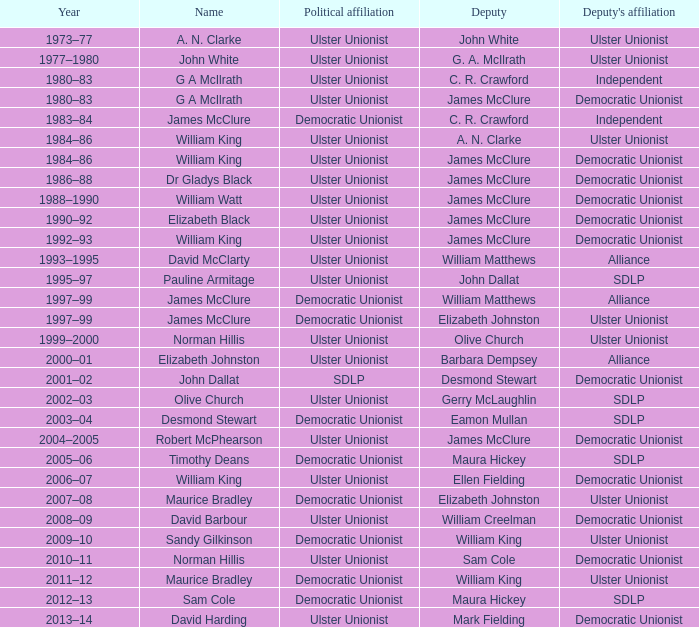What title is given to the years 1997 to 1999? James McClure, James McClure. 